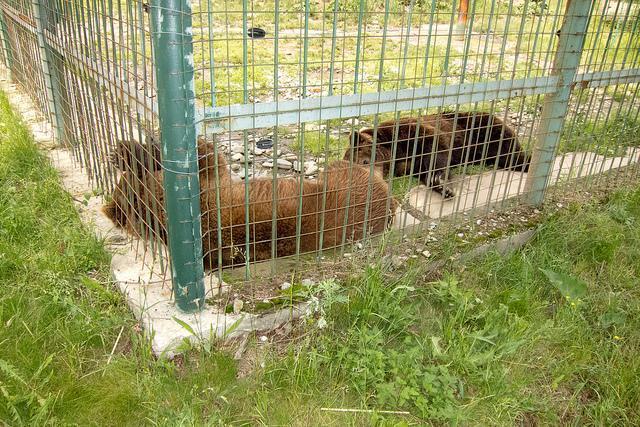How many animals are laying down?
Give a very brief answer. 2. How many bears are in the photo?
Give a very brief answer. 2. How many motorcycles have two helmets?
Give a very brief answer. 0. 